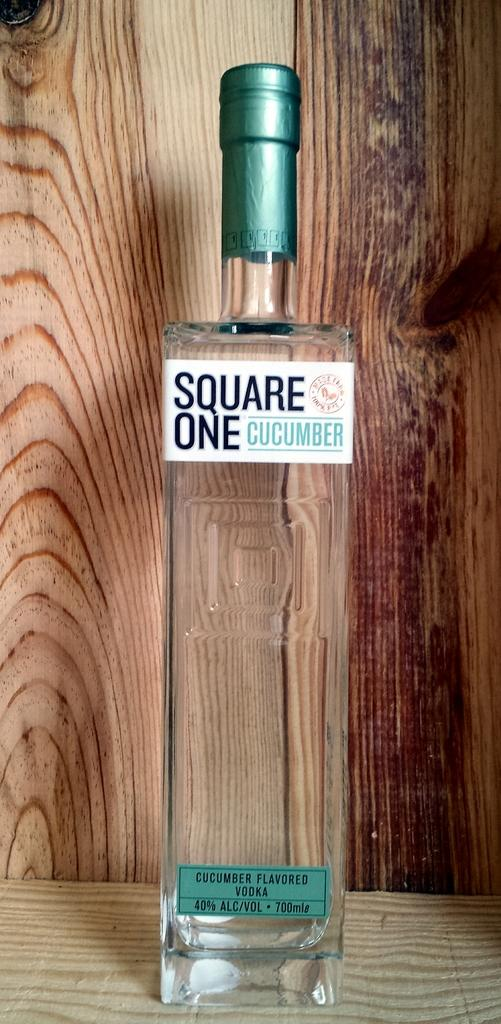<image>
Provide a brief description of the given image. A bottle of square one brand cucumber flavored vodka. 